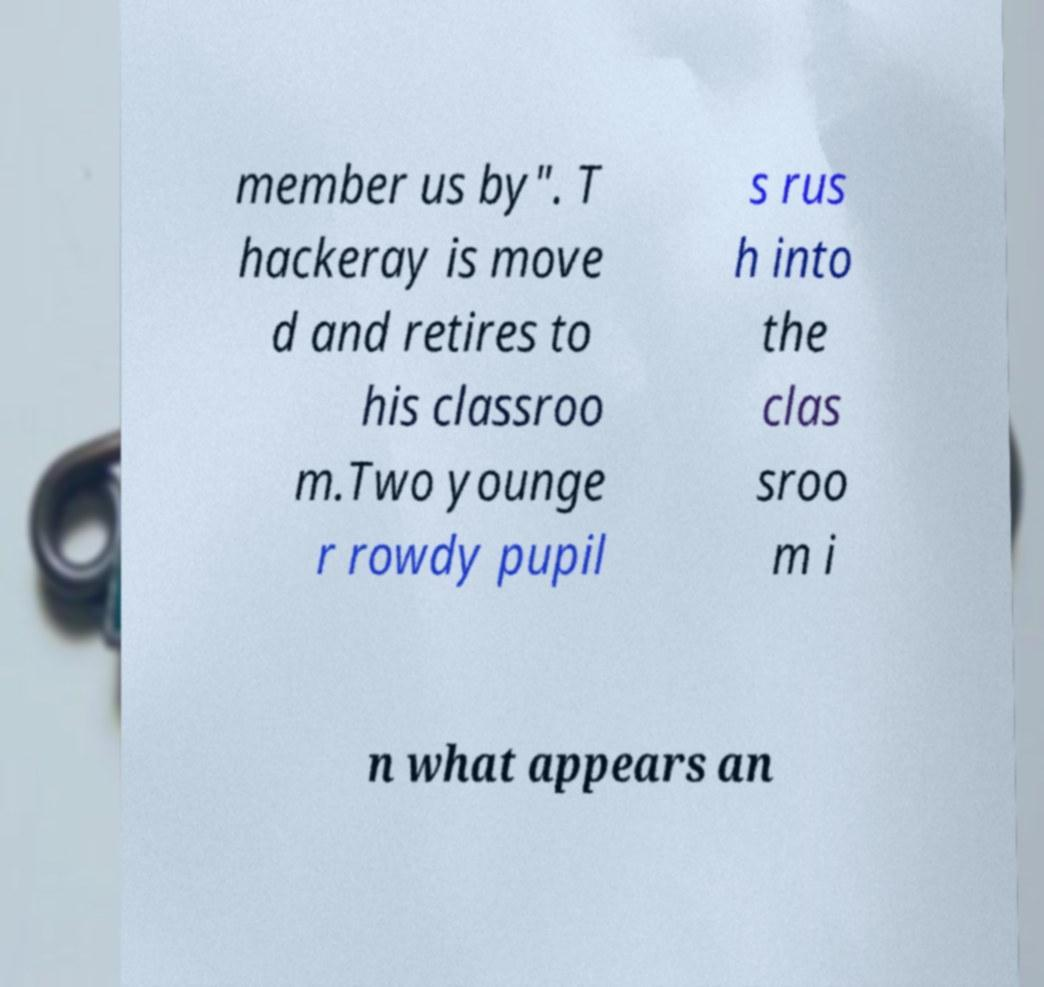What messages or text are displayed in this image? I need them in a readable, typed format. member us by". T hackeray is move d and retires to his classroo m.Two younge r rowdy pupil s rus h into the clas sroo m i n what appears an 